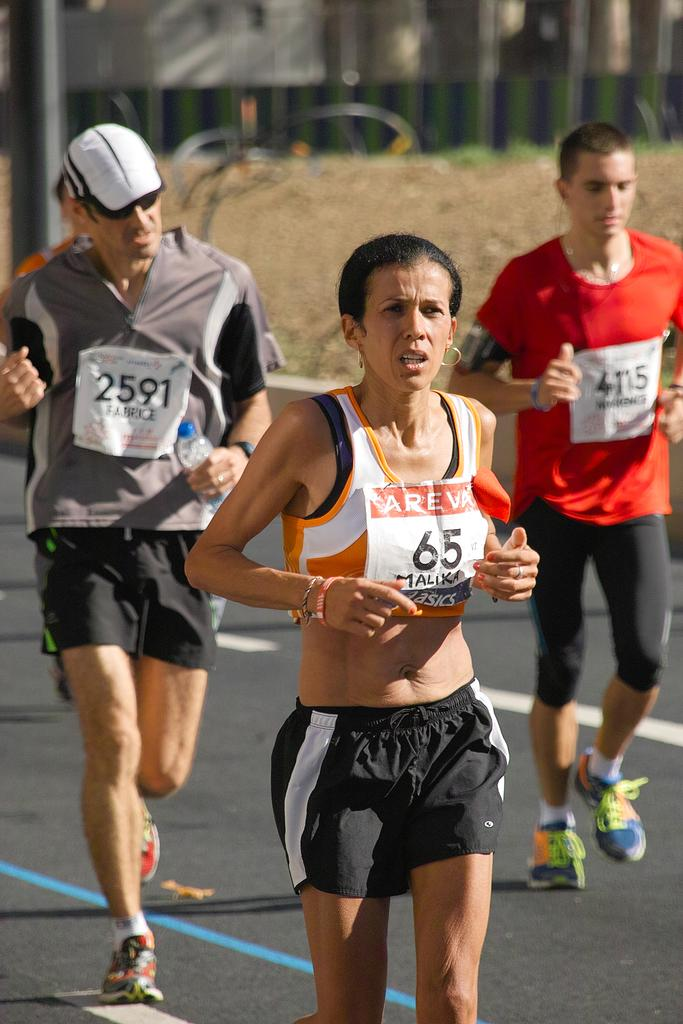<image>
Summarize the visual content of the image. A female running with the number 65 and two runners behind her. 